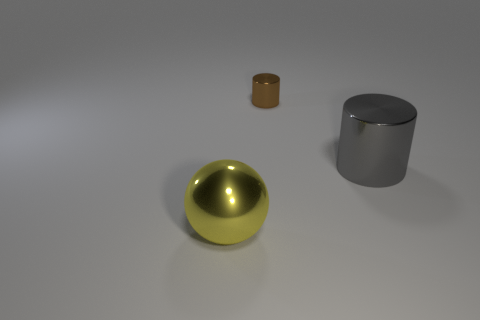How many small things are either gray shiny objects or brown cylinders?
Offer a very short reply. 1. How many big yellow metal things are there?
Make the answer very short. 1. What is the material of the large object that is behind the big yellow sphere?
Offer a very short reply. Metal. Are there any big gray cylinders behind the big yellow metal object?
Keep it short and to the point. Yes. Does the metal ball have the same size as the brown metallic cylinder?
Offer a very short reply. No. What number of other big objects have the same material as the yellow thing?
Make the answer very short. 1. What size is the metallic cylinder that is to the right of the metallic cylinder behind the big gray cylinder?
Provide a short and direct response. Large. There is a shiny thing that is both right of the ball and on the left side of the gray metal object; what is its color?
Your answer should be compact. Brown. Do the small thing and the gray metal object have the same shape?
Keep it short and to the point. Yes. What shape is the big thing that is to the right of the small brown shiny object that is left of the large cylinder?
Give a very brief answer. Cylinder. 